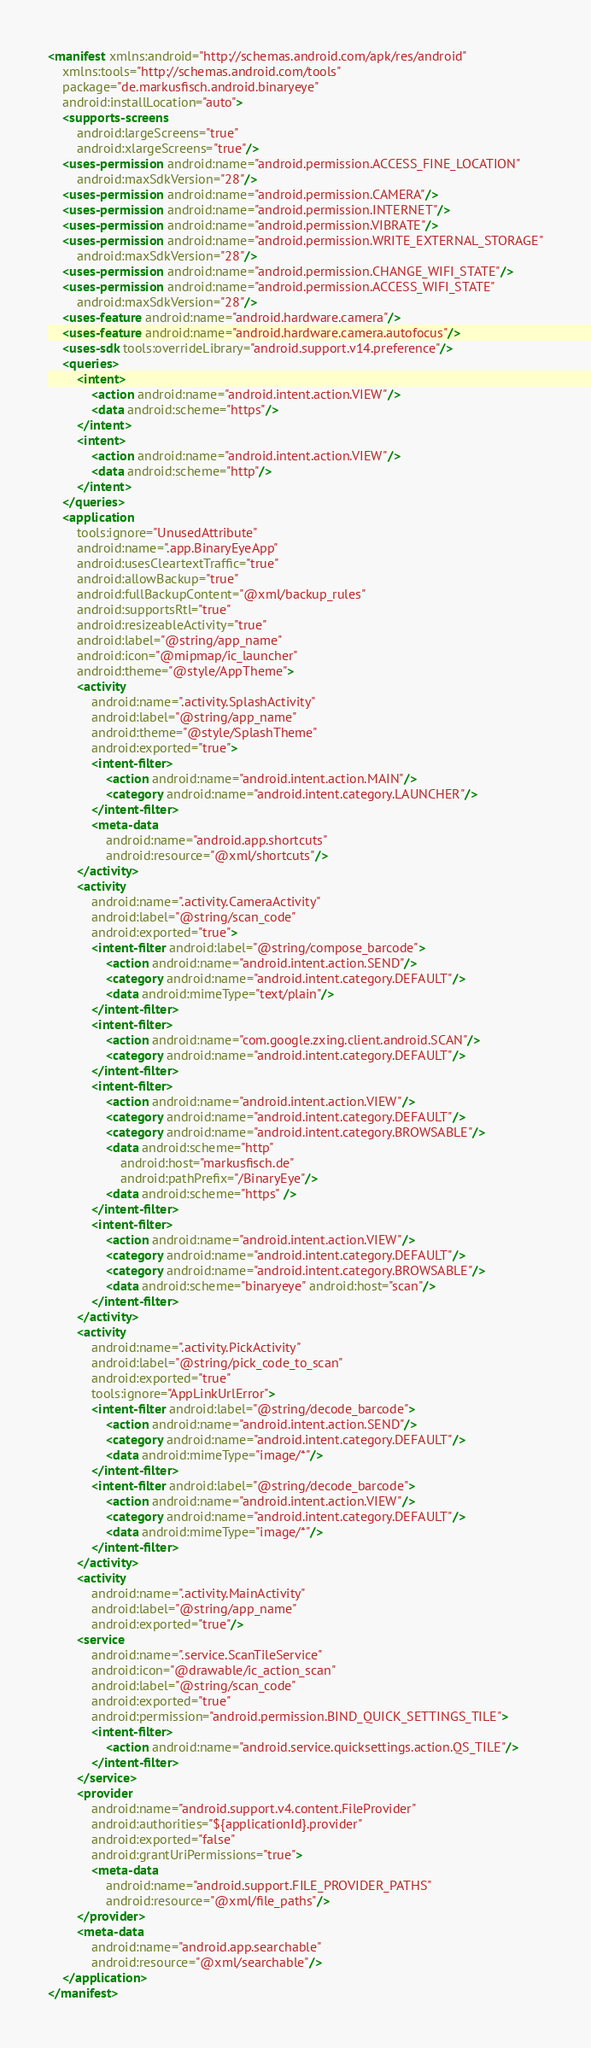<code> <loc_0><loc_0><loc_500><loc_500><_XML_><manifest xmlns:android="http://schemas.android.com/apk/res/android"
	xmlns:tools="http://schemas.android.com/tools"
	package="de.markusfisch.android.binaryeye"
	android:installLocation="auto">
	<supports-screens
		android:largeScreens="true"
		android:xlargeScreens="true"/>
	<uses-permission android:name="android.permission.ACCESS_FINE_LOCATION"
		android:maxSdkVersion="28"/>
	<uses-permission android:name="android.permission.CAMERA"/>
	<uses-permission android:name="android.permission.INTERNET"/>
	<uses-permission android:name="android.permission.VIBRATE"/>
	<uses-permission android:name="android.permission.WRITE_EXTERNAL_STORAGE"
		android:maxSdkVersion="28"/>
	<uses-permission android:name="android.permission.CHANGE_WIFI_STATE"/>
	<uses-permission android:name="android.permission.ACCESS_WIFI_STATE"
		android:maxSdkVersion="28"/>
	<uses-feature android:name="android.hardware.camera"/>
	<uses-feature android:name="android.hardware.camera.autofocus"/>
	<uses-sdk tools:overrideLibrary="android.support.v14.preference"/>
	<queries>
		<intent>
			<action android:name="android.intent.action.VIEW"/>
			<data android:scheme="https"/>
		</intent>
		<intent>
			<action android:name="android.intent.action.VIEW"/>
			<data android:scheme="http"/>
		</intent>
	</queries>
	<application
		tools:ignore="UnusedAttribute"
		android:name=".app.BinaryEyeApp"
		android:usesCleartextTraffic="true"
		android:allowBackup="true"
		android:fullBackupContent="@xml/backup_rules"
		android:supportsRtl="true"
		android:resizeableActivity="true"
		android:label="@string/app_name"
		android:icon="@mipmap/ic_launcher"
		android:theme="@style/AppTheme">
		<activity
			android:name=".activity.SplashActivity"
			android:label="@string/app_name"
			android:theme="@style/SplashTheme"
			android:exported="true">
			<intent-filter>
				<action android:name="android.intent.action.MAIN"/>
				<category android:name="android.intent.category.LAUNCHER"/>
			</intent-filter>
			<meta-data
				android:name="android.app.shortcuts"
				android:resource="@xml/shortcuts"/>
		</activity>
		<activity
			android:name=".activity.CameraActivity"
			android:label="@string/scan_code"
			android:exported="true">
			<intent-filter android:label="@string/compose_barcode">
				<action android:name="android.intent.action.SEND"/>
				<category android:name="android.intent.category.DEFAULT"/>
				<data android:mimeType="text/plain"/>
			</intent-filter>
			<intent-filter>
				<action android:name="com.google.zxing.client.android.SCAN"/>
				<category android:name="android.intent.category.DEFAULT"/>
			</intent-filter>
			<intent-filter>
				<action android:name="android.intent.action.VIEW"/>
				<category android:name="android.intent.category.DEFAULT"/>
				<category android:name="android.intent.category.BROWSABLE"/>
				<data android:scheme="http"
					android:host="markusfisch.de"
					android:pathPrefix="/BinaryEye"/>
				<data android:scheme="https" />
			</intent-filter>
			<intent-filter>
				<action android:name="android.intent.action.VIEW"/>
				<category android:name="android.intent.category.DEFAULT"/>
				<category android:name="android.intent.category.BROWSABLE"/>
				<data android:scheme="binaryeye" android:host="scan"/>
			</intent-filter>
		</activity>
		<activity
			android:name=".activity.PickActivity"
			android:label="@string/pick_code_to_scan"
			android:exported="true"
			tools:ignore="AppLinkUrlError">
			<intent-filter android:label="@string/decode_barcode">
				<action android:name="android.intent.action.SEND"/>
				<category android:name="android.intent.category.DEFAULT"/>
				<data android:mimeType="image/*"/>
			</intent-filter>
			<intent-filter android:label="@string/decode_barcode">
				<action android:name="android.intent.action.VIEW"/>
				<category android:name="android.intent.category.DEFAULT"/>
				<data android:mimeType="image/*"/>
			</intent-filter>
		</activity>
		<activity
			android:name=".activity.MainActivity"
			android:label="@string/app_name"
			android:exported="true"/>
		<service
			android:name=".service.ScanTileService"
			android:icon="@drawable/ic_action_scan"
			android:label="@string/scan_code"
			android:exported="true"
			android:permission="android.permission.BIND_QUICK_SETTINGS_TILE">
			<intent-filter>
				<action android:name="android.service.quicksettings.action.QS_TILE"/>
			</intent-filter>
		</service>
		<provider
			android:name="android.support.v4.content.FileProvider"
			android:authorities="${applicationId}.provider"
			android:exported="false"
			android:grantUriPermissions="true">
			<meta-data
				android:name="android.support.FILE_PROVIDER_PATHS"
				android:resource="@xml/file_paths"/>
		</provider>
		<meta-data
			android:name="android.app.searchable"
			android:resource="@xml/searchable"/>
	</application>
</manifest>
</code> 